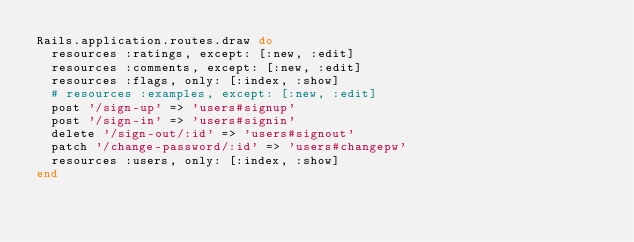Convert code to text. <code><loc_0><loc_0><loc_500><loc_500><_Ruby_>Rails.application.routes.draw do
  resources :ratings, except: [:new, :edit]
  resources :comments, except: [:new, :edit]
  resources :flags, only: [:index, :show]
  # resources :examples, except: [:new, :edit]
  post '/sign-up' => 'users#signup'
  post '/sign-in' => 'users#signin'
  delete '/sign-out/:id' => 'users#signout'
  patch '/change-password/:id' => 'users#changepw'
  resources :users, only: [:index, :show]
end
</code> 